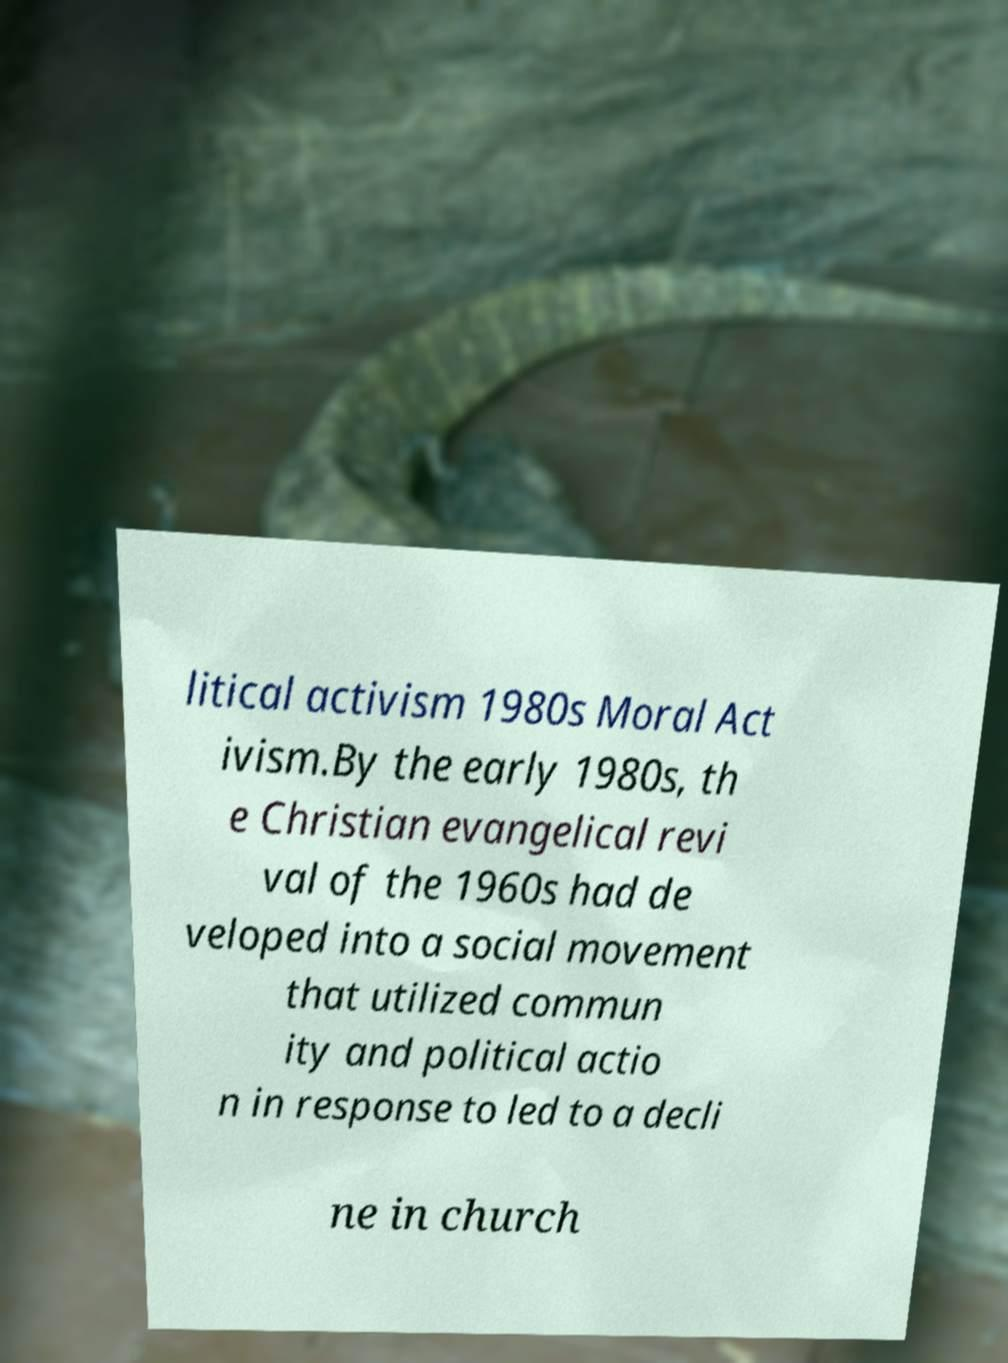Please identify and transcribe the text found in this image. litical activism 1980s Moral Act ivism.By the early 1980s, th e Christian evangelical revi val of the 1960s had de veloped into a social movement that utilized commun ity and political actio n in response to led to a decli ne in church 